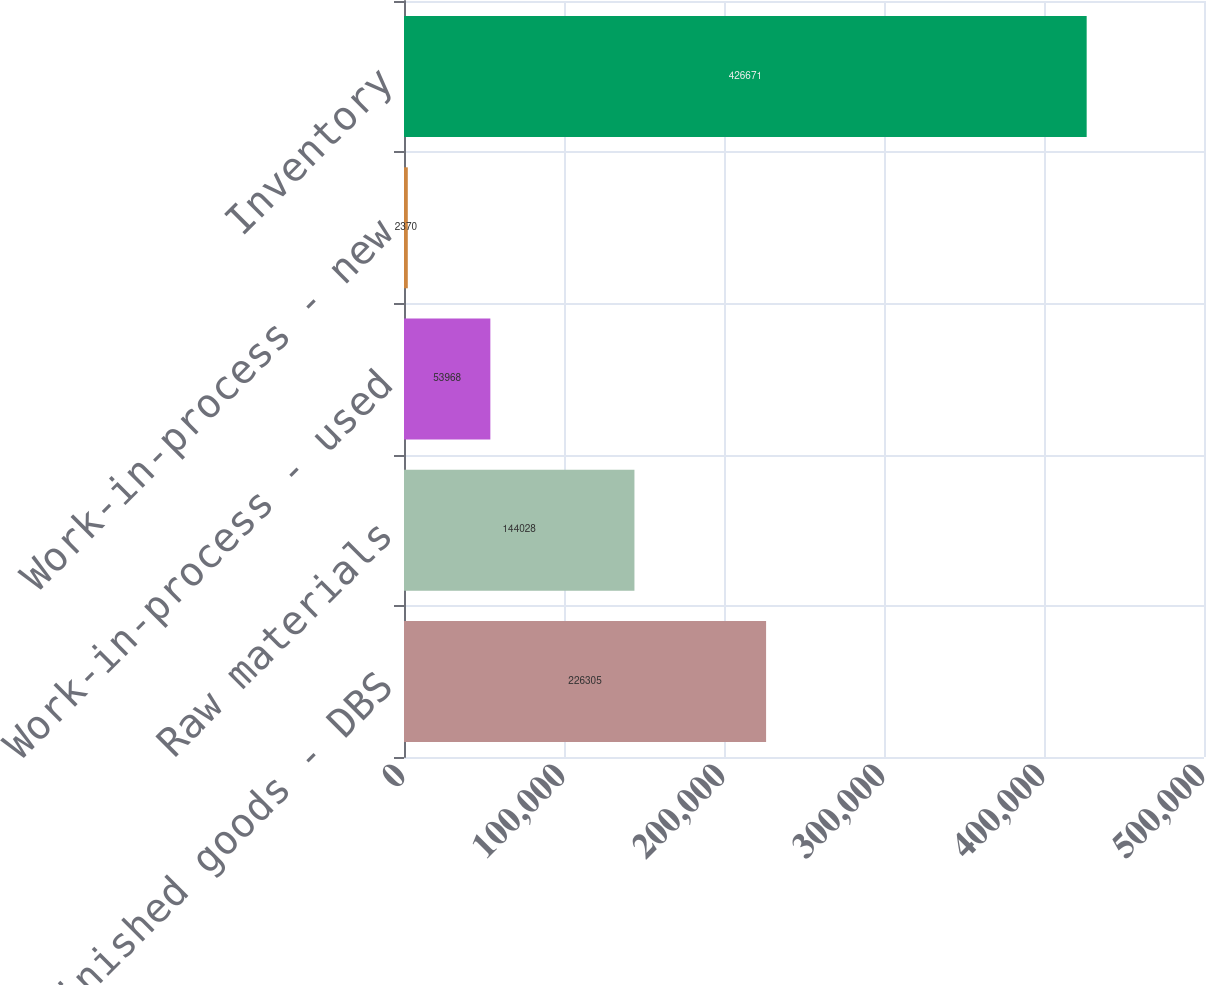Convert chart to OTSL. <chart><loc_0><loc_0><loc_500><loc_500><bar_chart><fcel>Finished goods - DBS<fcel>Raw materials<fcel>Work-in-process - used<fcel>Work-in-process - new<fcel>Inventory<nl><fcel>226305<fcel>144028<fcel>53968<fcel>2370<fcel>426671<nl></chart> 